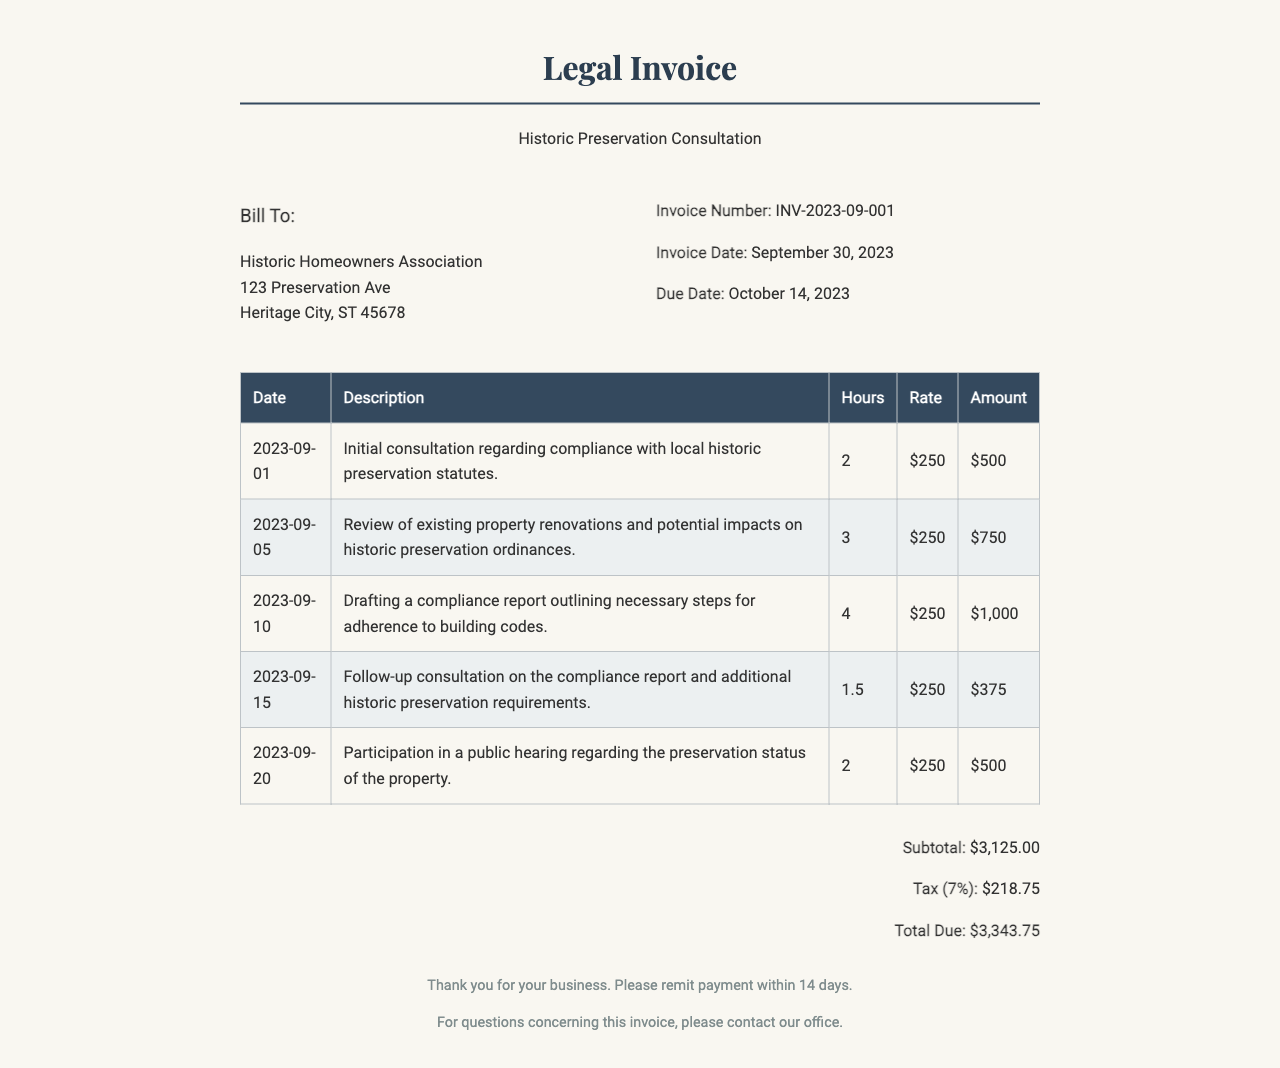What is the invoice number? The invoice number is provided in the invoice details section, labeled clearly.
Answer: INV-2023-09-001 What is the subtotal amount? The subtotal amount is shown before tax in the total section of the invoice.
Answer: $3,125.00 How many hours were worked on the compliance report? The hours for the compliance report are specifically listed in the itemized services table.
Answer: 4 What date was the initial consultation? The date for the initial consultation is included in the date column of the itemized services table.
Answer: 2023-09-01 What is the tax percentage applied? The tax percentage is indicated in the total section of the invoice.
Answer: 7% What is the total due amount? The total due is computed by adding the subtotal and tax in the total section.
Answer: $3,343.75 What was discussed in the follow-up consultation? The description of the follow-up consultation is provided in the itemized services.
Answer: Compliance report and additional historic preservation requirements How many days do you have to remit payment? The time frame for remitting payment is specified in the footer of the document.
Answer: 14 days What is the rate per hour charged? The rate per hour is consistent across the itemized services and is mentioned in the table.
Answer: $250 